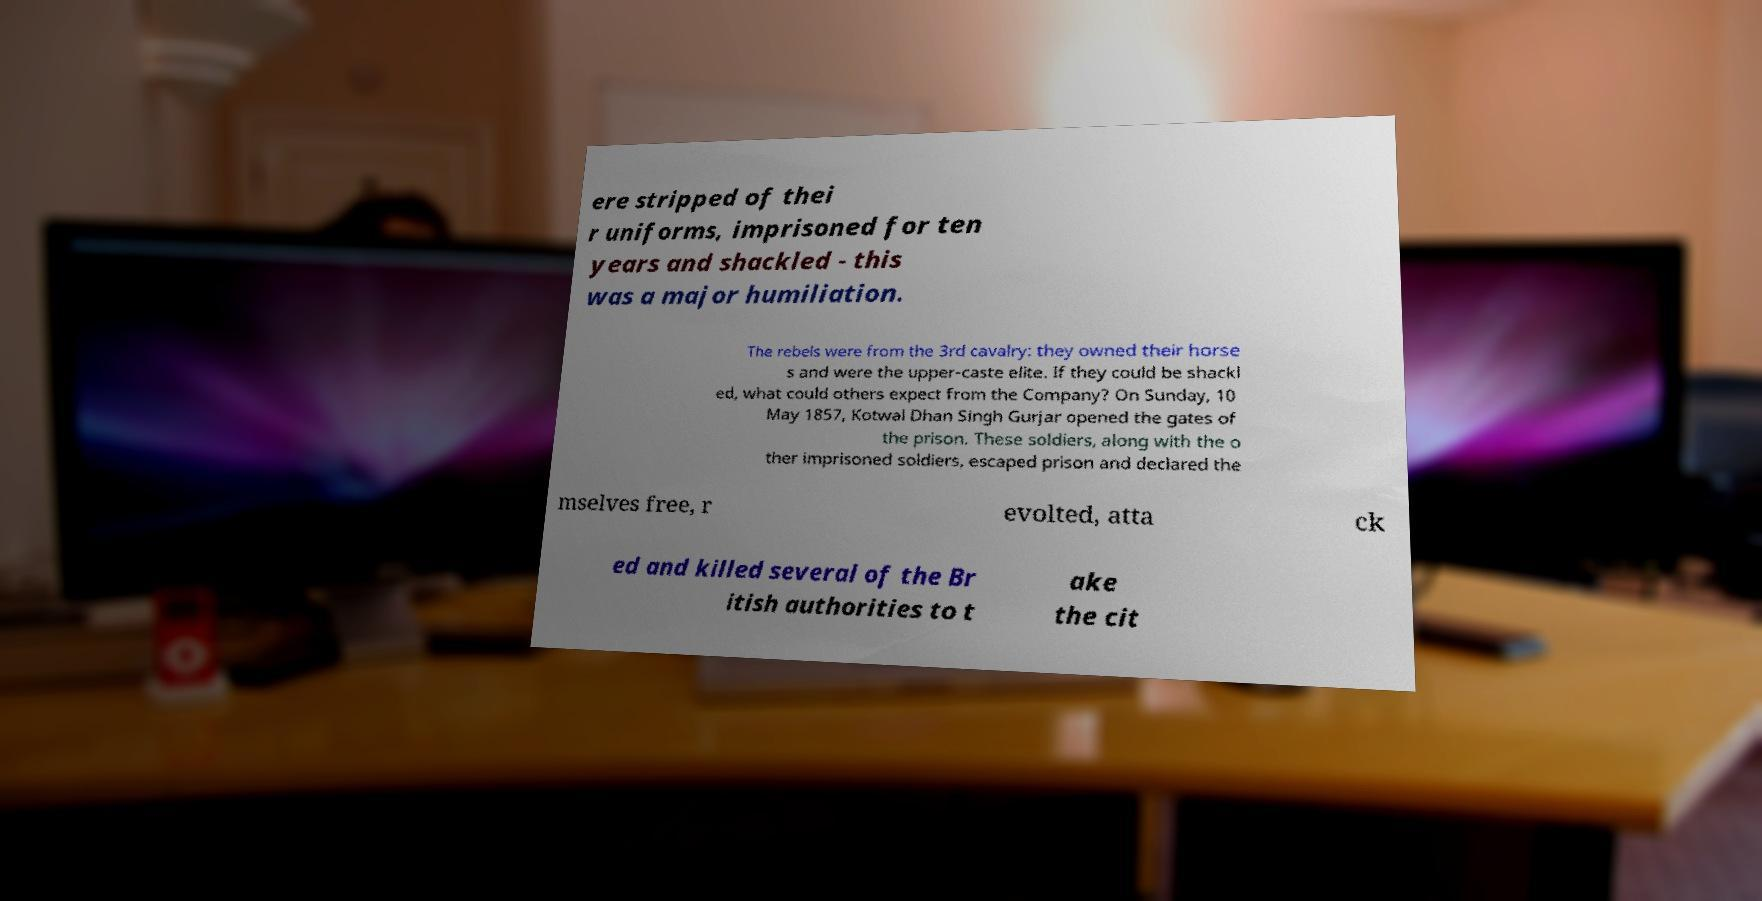Please identify and transcribe the text found in this image. ere stripped of thei r uniforms, imprisoned for ten years and shackled - this was a major humiliation. The rebels were from the 3rd cavalry: they owned their horse s and were the upper-caste elite. If they could be shackl ed, what could others expect from the Company? On Sunday, 10 May 1857, Kotwal Dhan Singh Gurjar opened the gates of the prison. These soldiers, along with the o ther imprisoned soldiers, escaped prison and declared the mselves free, r evolted, atta ck ed and killed several of the Br itish authorities to t ake the cit 